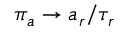Convert formula to latex. <formula><loc_0><loc_0><loc_500><loc_500>\pi _ { a } \to a _ { r } / \tau _ { r }</formula> 